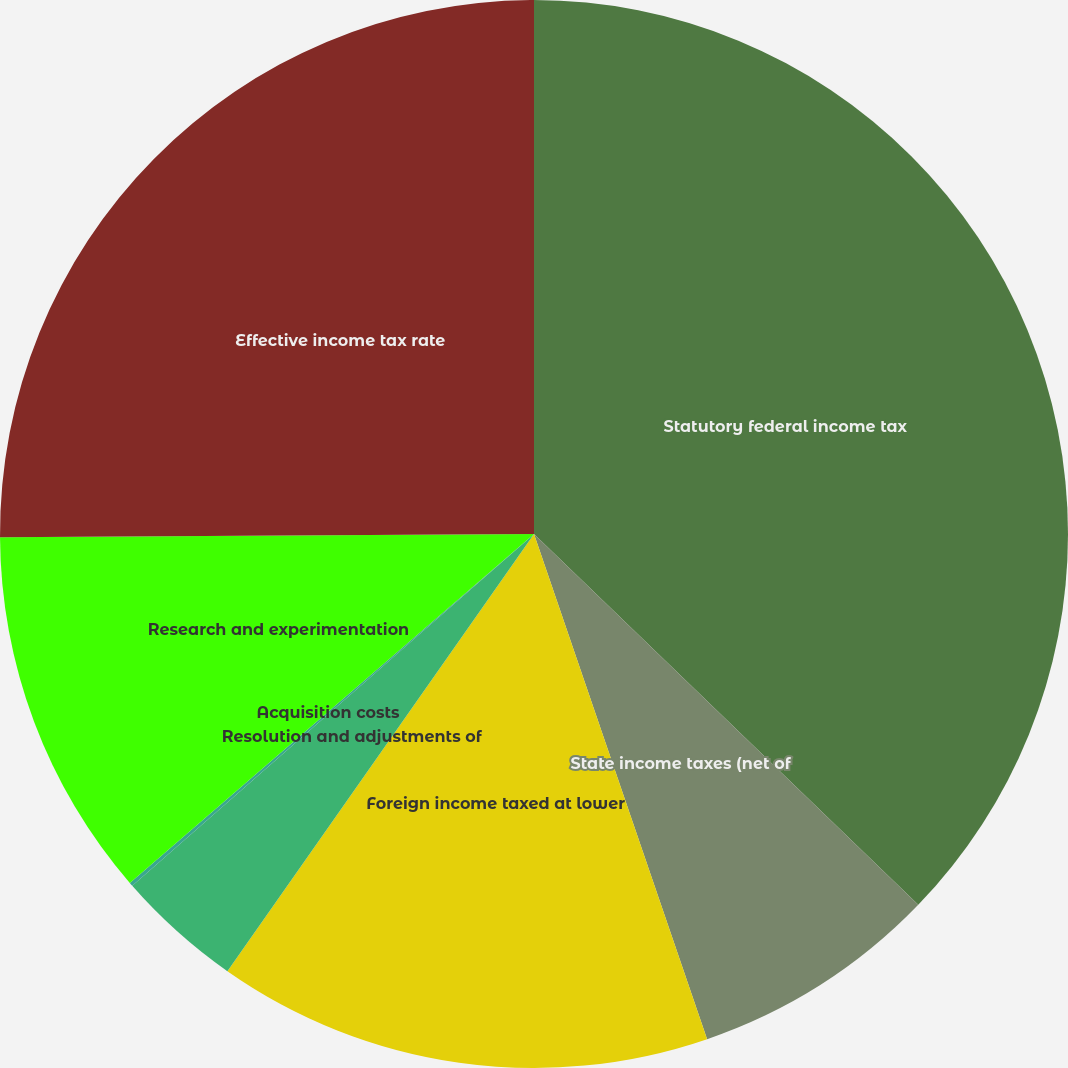Convert chart. <chart><loc_0><loc_0><loc_500><loc_500><pie_chart><fcel>Statutory federal income tax<fcel>State income taxes (net of<fcel>Foreign income taxed at lower<fcel>Resolution and adjustments of<fcel>Acquisition costs<fcel>Research and experimentation<fcel>Effective income tax rate<nl><fcel>37.22%<fcel>7.53%<fcel>14.99%<fcel>3.82%<fcel>0.11%<fcel>11.24%<fcel>25.1%<nl></chart> 